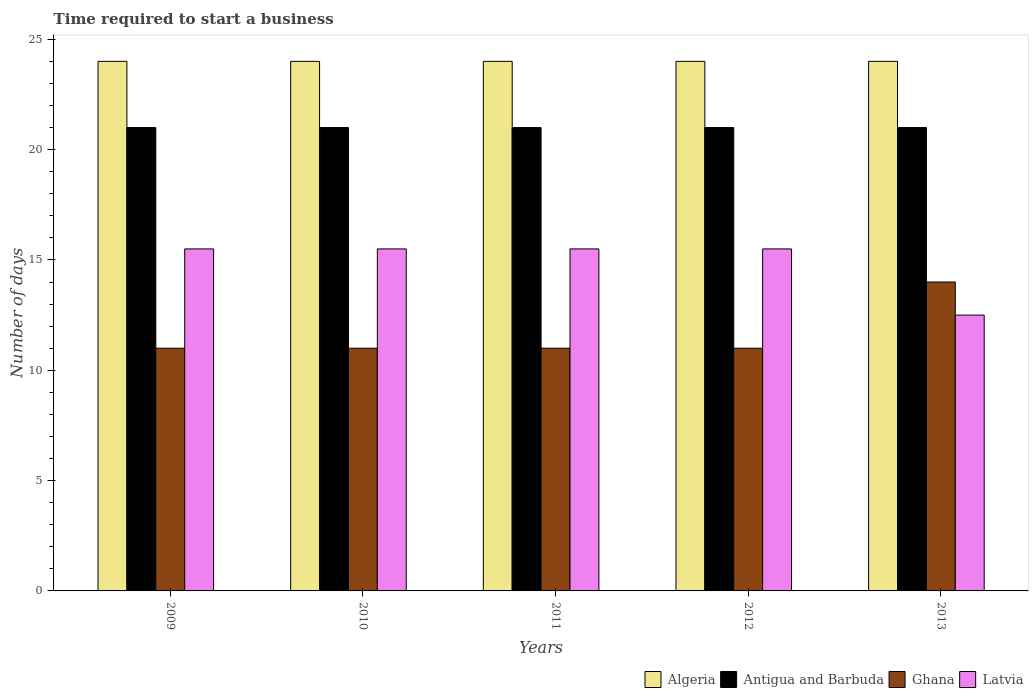How many different coloured bars are there?
Give a very brief answer. 4. How many bars are there on the 4th tick from the left?
Give a very brief answer. 4. What is the number of days required to start a business in Latvia in 2011?
Provide a succinct answer. 15.5. Across all years, what is the maximum number of days required to start a business in Latvia?
Provide a short and direct response. 15.5. Across all years, what is the minimum number of days required to start a business in Algeria?
Offer a terse response. 24. What is the total number of days required to start a business in Algeria in the graph?
Offer a very short reply. 120. What is the difference between the number of days required to start a business in Algeria in 2009 and that in 2010?
Ensure brevity in your answer.  0. In how many years, is the number of days required to start a business in Ghana greater than 18 days?
Your response must be concise. 0. Is the difference between the number of days required to start a business in Antigua and Barbuda in 2009 and 2010 greater than the difference between the number of days required to start a business in Latvia in 2009 and 2010?
Keep it short and to the point. No. What is the difference between the highest and the second highest number of days required to start a business in Ghana?
Your answer should be compact. 3. What is the difference between the highest and the lowest number of days required to start a business in Algeria?
Provide a short and direct response. 0. What does the 4th bar from the left in 2012 represents?
Ensure brevity in your answer.  Latvia. What is the difference between two consecutive major ticks on the Y-axis?
Provide a succinct answer. 5. Are the values on the major ticks of Y-axis written in scientific E-notation?
Your response must be concise. No. Does the graph contain grids?
Offer a very short reply. No. Where does the legend appear in the graph?
Offer a very short reply. Bottom right. What is the title of the graph?
Make the answer very short. Time required to start a business. What is the label or title of the X-axis?
Ensure brevity in your answer.  Years. What is the label or title of the Y-axis?
Offer a terse response. Number of days. What is the Number of days in Ghana in 2009?
Make the answer very short. 11. What is the Number of days in Algeria in 2010?
Your answer should be compact. 24. What is the Number of days of Ghana in 2010?
Ensure brevity in your answer.  11. What is the Number of days in Latvia in 2010?
Make the answer very short. 15.5. What is the Number of days in Algeria in 2012?
Provide a short and direct response. 24. What is the Number of days in Ghana in 2012?
Keep it short and to the point. 11. What is the Number of days of Latvia in 2012?
Provide a short and direct response. 15.5. What is the Number of days in Ghana in 2013?
Offer a terse response. 14. Across all years, what is the maximum Number of days of Latvia?
Your answer should be very brief. 15.5. Across all years, what is the minimum Number of days of Antigua and Barbuda?
Provide a short and direct response. 21. What is the total Number of days of Algeria in the graph?
Your response must be concise. 120. What is the total Number of days of Antigua and Barbuda in the graph?
Offer a very short reply. 105. What is the total Number of days in Latvia in the graph?
Your response must be concise. 74.5. What is the difference between the Number of days of Antigua and Barbuda in 2009 and that in 2010?
Make the answer very short. 0. What is the difference between the Number of days of Ghana in 2009 and that in 2010?
Ensure brevity in your answer.  0. What is the difference between the Number of days of Latvia in 2009 and that in 2010?
Offer a very short reply. 0. What is the difference between the Number of days in Ghana in 2009 and that in 2011?
Your response must be concise. 0. What is the difference between the Number of days of Algeria in 2009 and that in 2012?
Keep it short and to the point. 0. What is the difference between the Number of days of Latvia in 2009 and that in 2012?
Keep it short and to the point. 0. What is the difference between the Number of days of Algeria in 2009 and that in 2013?
Offer a very short reply. 0. What is the difference between the Number of days of Antigua and Barbuda in 2009 and that in 2013?
Offer a terse response. 0. What is the difference between the Number of days of Ghana in 2009 and that in 2013?
Ensure brevity in your answer.  -3. What is the difference between the Number of days of Algeria in 2010 and that in 2011?
Your answer should be compact. 0. What is the difference between the Number of days of Antigua and Barbuda in 2010 and that in 2011?
Give a very brief answer. 0. What is the difference between the Number of days of Latvia in 2010 and that in 2011?
Ensure brevity in your answer.  0. What is the difference between the Number of days in Antigua and Barbuda in 2010 and that in 2012?
Make the answer very short. 0. What is the difference between the Number of days in Ghana in 2010 and that in 2012?
Offer a very short reply. 0. What is the difference between the Number of days of Latvia in 2010 and that in 2012?
Keep it short and to the point. 0. What is the difference between the Number of days of Algeria in 2010 and that in 2013?
Offer a very short reply. 0. What is the difference between the Number of days in Latvia in 2010 and that in 2013?
Give a very brief answer. 3. What is the difference between the Number of days in Algeria in 2011 and that in 2012?
Provide a short and direct response. 0. What is the difference between the Number of days in Antigua and Barbuda in 2011 and that in 2012?
Offer a terse response. 0. What is the difference between the Number of days in Ghana in 2011 and that in 2012?
Provide a succinct answer. 0. What is the difference between the Number of days of Latvia in 2011 and that in 2012?
Keep it short and to the point. 0. What is the difference between the Number of days of Algeria in 2012 and that in 2013?
Provide a short and direct response. 0. What is the difference between the Number of days in Antigua and Barbuda in 2012 and that in 2013?
Make the answer very short. 0. What is the difference between the Number of days in Ghana in 2012 and that in 2013?
Your answer should be very brief. -3. What is the difference between the Number of days in Algeria in 2009 and the Number of days in Ghana in 2010?
Provide a succinct answer. 13. What is the difference between the Number of days of Ghana in 2009 and the Number of days of Latvia in 2010?
Make the answer very short. -4.5. What is the difference between the Number of days in Algeria in 2009 and the Number of days in Latvia in 2011?
Provide a short and direct response. 8.5. What is the difference between the Number of days in Antigua and Barbuda in 2009 and the Number of days in Ghana in 2011?
Provide a short and direct response. 10. What is the difference between the Number of days in Ghana in 2009 and the Number of days in Latvia in 2012?
Offer a very short reply. -4.5. What is the difference between the Number of days of Algeria in 2009 and the Number of days of Antigua and Barbuda in 2013?
Your answer should be compact. 3. What is the difference between the Number of days of Algeria in 2009 and the Number of days of Latvia in 2013?
Keep it short and to the point. 11.5. What is the difference between the Number of days of Antigua and Barbuda in 2009 and the Number of days of Latvia in 2013?
Your answer should be very brief. 8.5. What is the difference between the Number of days of Algeria in 2010 and the Number of days of Antigua and Barbuda in 2011?
Your answer should be very brief. 3. What is the difference between the Number of days of Algeria in 2010 and the Number of days of Latvia in 2011?
Provide a succinct answer. 8.5. What is the difference between the Number of days of Algeria in 2010 and the Number of days of Antigua and Barbuda in 2012?
Offer a very short reply. 3. What is the difference between the Number of days of Algeria in 2010 and the Number of days of Latvia in 2012?
Offer a terse response. 8.5. What is the difference between the Number of days of Antigua and Barbuda in 2010 and the Number of days of Ghana in 2012?
Give a very brief answer. 10. What is the difference between the Number of days of Ghana in 2010 and the Number of days of Latvia in 2012?
Offer a very short reply. -4.5. What is the difference between the Number of days of Algeria in 2010 and the Number of days of Antigua and Barbuda in 2013?
Provide a short and direct response. 3. What is the difference between the Number of days in Algeria in 2010 and the Number of days in Ghana in 2013?
Provide a short and direct response. 10. What is the difference between the Number of days of Antigua and Barbuda in 2010 and the Number of days of Ghana in 2013?
Ensure brevity in your answer.  7. What is the difference between the Number of days of Antigua and Barbuda in 2010 and the Number of days of Latvia in 2013?
Make the answer very short. 8.5. What is the difference between the Number of days in Algeria in 2011 and the Number of days in Antigua and Barbuda in 2012?
Your response must be concise. 3. What is the difference between the Number of days in Algeria in 2011 and the Number of days in Antigua and Barbuda in 2013?
Your response must be concise. 3. What is the difference between the Number of days of Algeria in 2011 and the Number of days of Ghana in 2013?
Offer a terse response. 10. What is the difference between the Number of days of Antigua and Barbuda in 2011 and the Number of days of Ghana in 2013?
Provide a succinct answer. 7. What is the difference between the Number of days in Antigua and Barbuda in 2011 and the Number of days in Latvia in 2013?
Offer a terse response. 8.5. What is the difference between the Number of days in Ghana in 2011 and the Number of days in Latvia in 2013?
Your answer should be compact. -1.5. What is the difference between the Number of days of Algeria in 2012 and the Number of days of Antigua and Barbuda in 2013?
Keep it short and to the point. 3. What is the difference between the Number of days of Algeria in 2012 and the Number of days of Latvia in 2013?
Provide a succinct answer. 11.5. What is the difference between the Number of days in Antigua and Barbuda in 2012 and the Number of days in Latvia in 2013?
Provide a short and direct response. 8.5. What is the average Number of days in Antigua and Barbuda per year?
Give a very brief answer. 21. What is the average Number of days in Ghana per year?
Your answer should be very brief. 11.6. In the year 2009, what is the difference between the Number of days in Algeria and Number of days in Antigua and Barbuda?
Provide a succinct answer. 3. In the year 2009, what is the difference between the Number of days in Antigua and Barbuda and Number of days in Ghana?
Give a very brief answer. 10. In the year 2009, what is the difference between the Number of days in Antigua and Barbuda and Number of days in Latvia?
Give a very brief answer. 5.5. In the year 2010, what is the difference between the Number of days in Ghana and Number of days in Latvia?
Your answer should be very brief. -4.5. In the year 2011, what is the difference between the Number of days in Algeria and Number of days in Latvia?
Keep it short and to the point. 8.5. In the year 2011, what is the difference between the Number of days in Antigua and Barbuda and Number of days in Latvia?
Offer a very short reply. 5.5. In the year 2012, what is the difference between the Number of days of Algeria and Number of days of Antigua and Barbuda?
Give a very brief answer. 3. In the year 2012, what is the difference between the Number of days of Algeria and Number of days of Latvia?
Provide a succinct answer. 8.5. In the year 2012, what is the difference between the Number of days of Antigua and Barbuda and Number of days of Ghana?
Keep it short and to the point. 10. In the year 2013, what is the difference between the Number of days in Algeria and Number of days in Ghana?
Provide a short and direct response. 10. In the year 2013, what is the difference between the Number of days in Algeria and Number of days in Latvia?
Provide a short and direct response. 11.5. What is the ratio of the Number of days of Ghana in 2009 to that in 2010?
Keep it short and to the point. 1. What is the ratio of the Number of days in Latvia in 2009 to that in 2010?
Provide a succinct answer. 1. What is the ratio of the Number of days in Algeria in 2009 to that in 2011?
Provide a succinct answer. 1. What is the ratio of the Number of days of Antigua and Barbuda in 2009 to that in 2011?
Keep it short and to the point. 1. What is the ratio of the Number of days in Latvia in 2009 to that in 2011?
Ensure brevity in your answer.  1. What is the ratio of the Number of days of Algeria in 2009 to that in 2012?
Give a very brief answer. 1. What is the ratio of the Number of days in Antigua and Barbuda in 2009 to that in 2012?
Provide a short and direct response. 1. What is the ratio of the Number of days in Ghana in 2009 to that in 2012?
Your response must be concise. 1. What is the ratio of the Number of days of Latvia in 2009 to that in 2012?
Make the answer very short. 1. What is the ratio of the Number of days in Algeria in 2009 to that in 2013?
Give a very brief answer. 1. What is the ratio of the Number of days of Antigua and Barbuda in 2009 to that in 2013?
Offer a very short reply. 1. What is the ratio of the Number of days of Ghana in 2009 to that in 2013?
Give a very brief answer. 0.79. What is the ratio of the Number of days of Latvia in 2009 to that in 2013?
Keep it short and to the point. 1.24. What is the ratio of the Number of days of Latvia in 2010 to that in 2011?
Make the answer very short. 1. What is the ratio of the Number of days of Algeria in 2010 to that in 2012?
Your answer should be compact. 1. What is the ratio of the Number of days of Ghana in 2010 to that in 2012?
Provide a short and direct response. 1. What is the ratio of the Number of days of Latvia in 2010 to that in 2012?
Your answer should be compact. 1. What is the ratio of the Number of days in Antigua and Barbuda in 2010 to that in 2013?
Ensure brevity in your answer.  1. What is the ratio of the Number of days of Ghana in 2010 to that in 2013?
Keep it short and to the point. 0.79. What is the ratio of the Number of days in Latvia in 2010 to that in 2013?
Ensure brevity in your answer.  1.24. What is the ratio of the Number of days in Algeria in 2011 to that in 2012?
Keep it short and to the point. 1. What is the ratio of the Number of days of Antigua and Barbuda in 2011 to that in 2012?
Your answer should be compact. 1. What is the ratio of the Number of days in Ghana in 2011 to that in 2012?
Your answer should be very brief. 1. What is the ratio of the Number of days in Latvia in 2011 to that in 2012?
Your answer should be compact. 1. What is the ratio of the Number of days of Algeria in 2011 to that in 2013?
Provide a succinct answer. 1. What is the ratio of the Number of days of Ghana in 2011 to that in 2013?
Make the answer very short. 0.79. What is the ratio of the Number of days in Latvia in 2011 to that in 2013?
Offer a terse response. 1.24. What is the ratio of the Number of days of Algeria in 2012 to that in 2013?
Offer a very short reply. 1. What is the ratio of the Number of days in Antigua and Barbuda in 2012 to that in 2013?
Ensure brevity in your answer.  1. What is the ratio of the Number of days in Ghana in 2012 to that in 2013?
Your response must be concise. 0.79. What is the ratio of the Number of days in Latvia in 2012 to that in 2013?
Ensure brevity in your answer.  1.24. What is the difference between the highest and the second highest Number of days in Algeria?
Offer a very short reply. 0. What is the difference between the highest and the second highest Number of days in Antigua and Barbuda?
Ensure brevity in your answer.  0. What is the difference between the highest and the second highest Number of days of Ghana?
Provide a succinct answer. 3. What is the difference between the highest and the second highest Number of days of Latvia?
Give a very brief answer. 0. What is the difference between the highest and the lowest Number of days in Antigua and Barbuda?
Offer a very short reply. 0. 